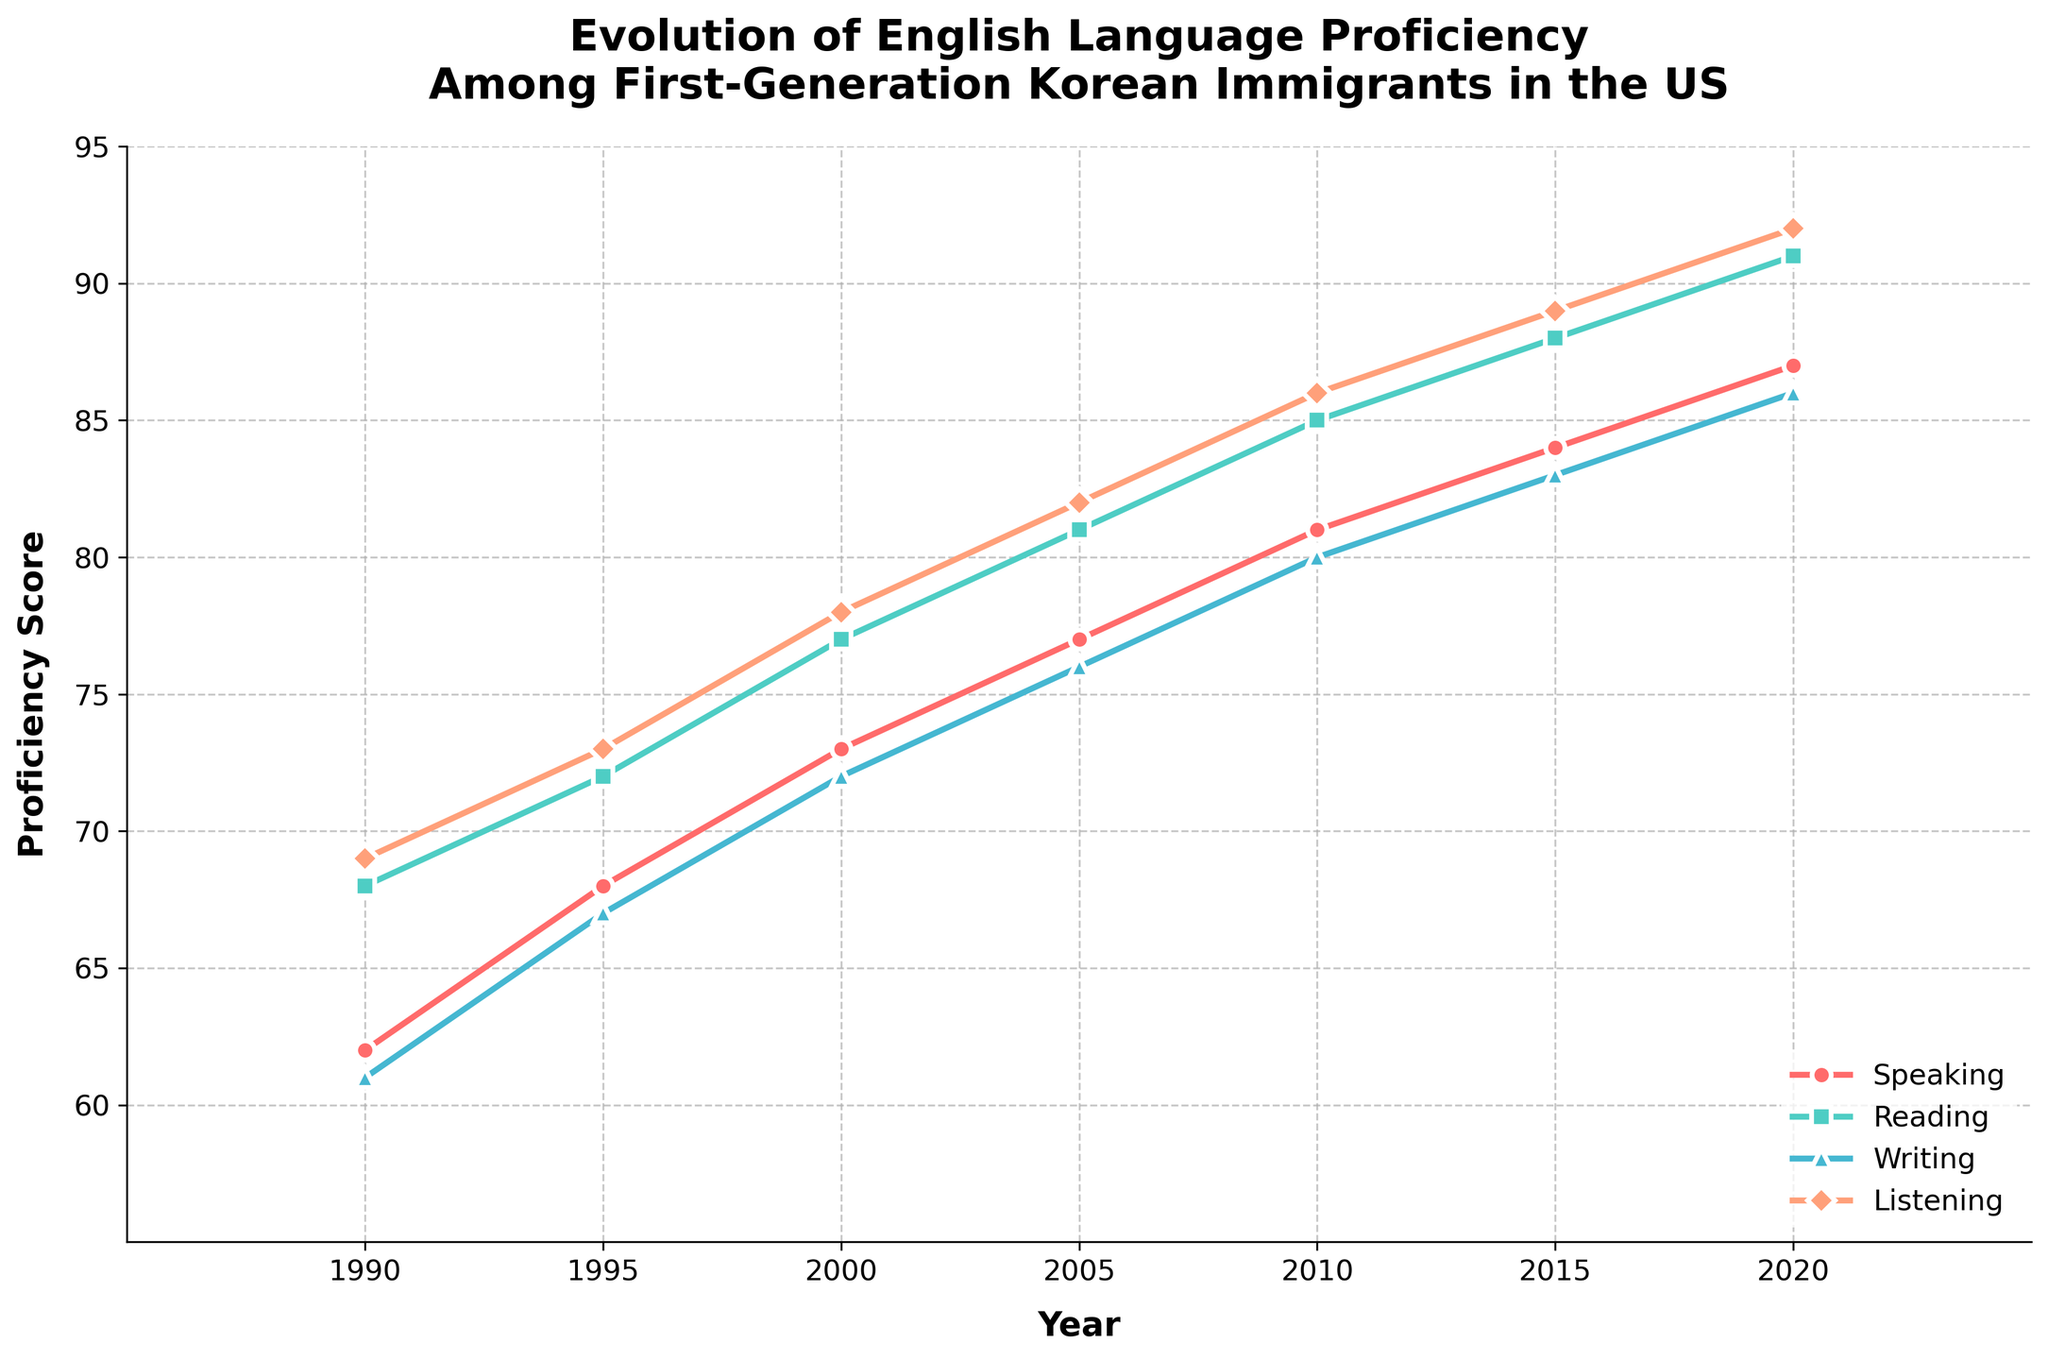How did the English proficiency score change overall from 1990 to 2020? The English proficiency score increased from 65 in 1990 to 89 in 2020. This can be observed by looking at the first and last proficiency score values in the figure.
Answer: It increased by 24 points Which year had the same score for reading and listening proficiency? By examining the lines for reading and listening, they intersect in 2000 where both scores are 78.
Answer: 2000 Between 1995 and 2005, which language skill showed the greatest increase in proficiency score? Calculating the increases in proficiency scores for each skill between 1995 and 2005: 
Speaking (77-68 = 9), Reading (81-72 = 9), Writing (76-67 = 9), Listening (82-73 = 9). Here, all skills increased by the same amount.
Answer: All skills increased equally What's the difference between the reading proficiency scores in 1990 and 2005? The reading proficiency score in 2005 was 81 and in 1990 it was 68. The difference is 81 - 68.
Answer: 13 Compare the proportional change in writing proficiency between 1990 to 2000 and 2000 to 2010. From 1990 to 2000, the writing proficiency increased from 61 to 72, a proportional change of (72-61)/61 = 0.18. From 2000 to 2010, it increased from 72 to 80, a proportional change of (80-72)/72 = 0.11.
Answer: 0.18 and 0.11 Which proficiency skill consistently had the highest score over the years? By comparing the lines for all proficiency skills, we see that the listening proficiency consistently had the highest scores each year.
Answer: Listening In which years did speaking proficiency have a score higher than 80? The years when the speaking proficiency score was higher than 80 are observed from the chart: 2010, 2015, and 2020.
Answer: 2010, 2015, and 2020 By how many points did the listening proficiency score improve from 1990 to 1995? The listening proficiency score for 1990 is 69 and for 1995 is 73. Therefore, the score improved by 73 - 69 points.
Answer: 4 What was the average writing proficiency score over the given years? The writing proficiency scores are 61, 67, 72, 76, 80, 83, and 86. The average is calculated as (61+67+72+76+80+83+86)/7.
Answer: 75 What is the overall trend in English language proficiency from 1990 to 2020? Observing the chart, it's evident that all English language proficiency skills have shown an increasing trend from 1990 to 2020. Each skill's line steadily moves upwards over time.
Answer: Increasing 